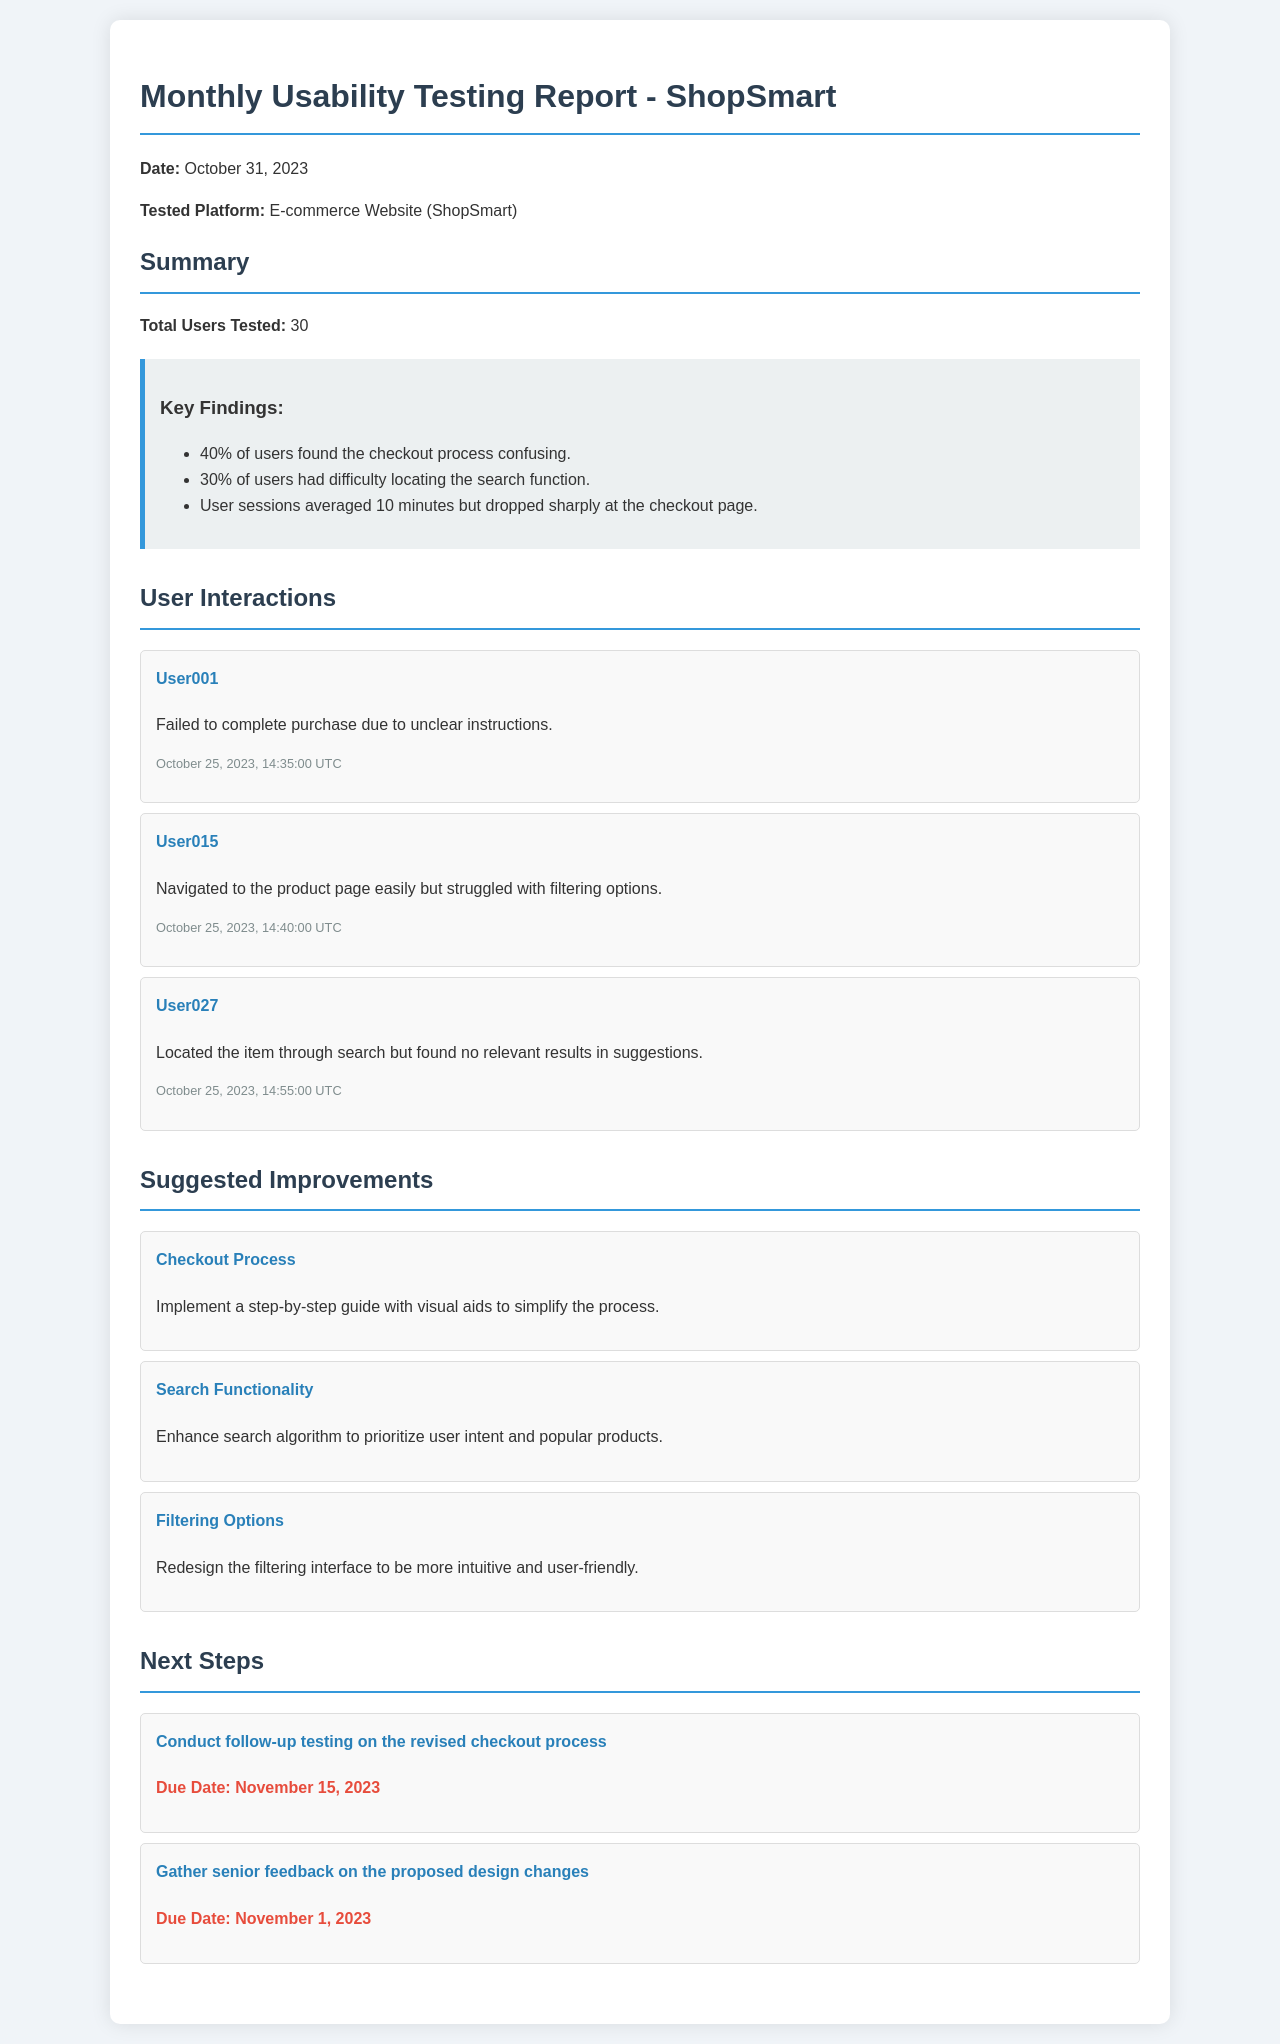what is the total number of users tested? The total number of users tested is mentioned in the summary section of the document.
Answer: 30 what percentage of users found the checkout process confusing? The percentage is specified under key findings in the summary section.
Answer: 40% who struggled with filtering options? User interactions list the specific user and their struggles.
Answer: User015 what is the due date for gathering senior feedback? The due date for this task is given in the next steps section.
Answer: November 1, 2023 what is one recommended improvement for the search functionality? Suggested improvements provide specific recommendations for each issue identified.
Answer: Enhance search algorithm to prioritize user intent and popular products how long did user sessions average? User session duration is stated in the summary section.
Answer: 10 minutes what was the main reason User001 failed to complete the purchase? The interaction item describes the user’s specific issue in detail.
Answer: Unclear instructions what is one of the next steps listed in the report? The next steps section outlines specific actions to be taken after the report.
Answer: Conduct follow-up testing on the revised checkout process what color is used for the background of the report? The color scheme of the document is mentioned in the styling details.
Answer: #f0f4f8 